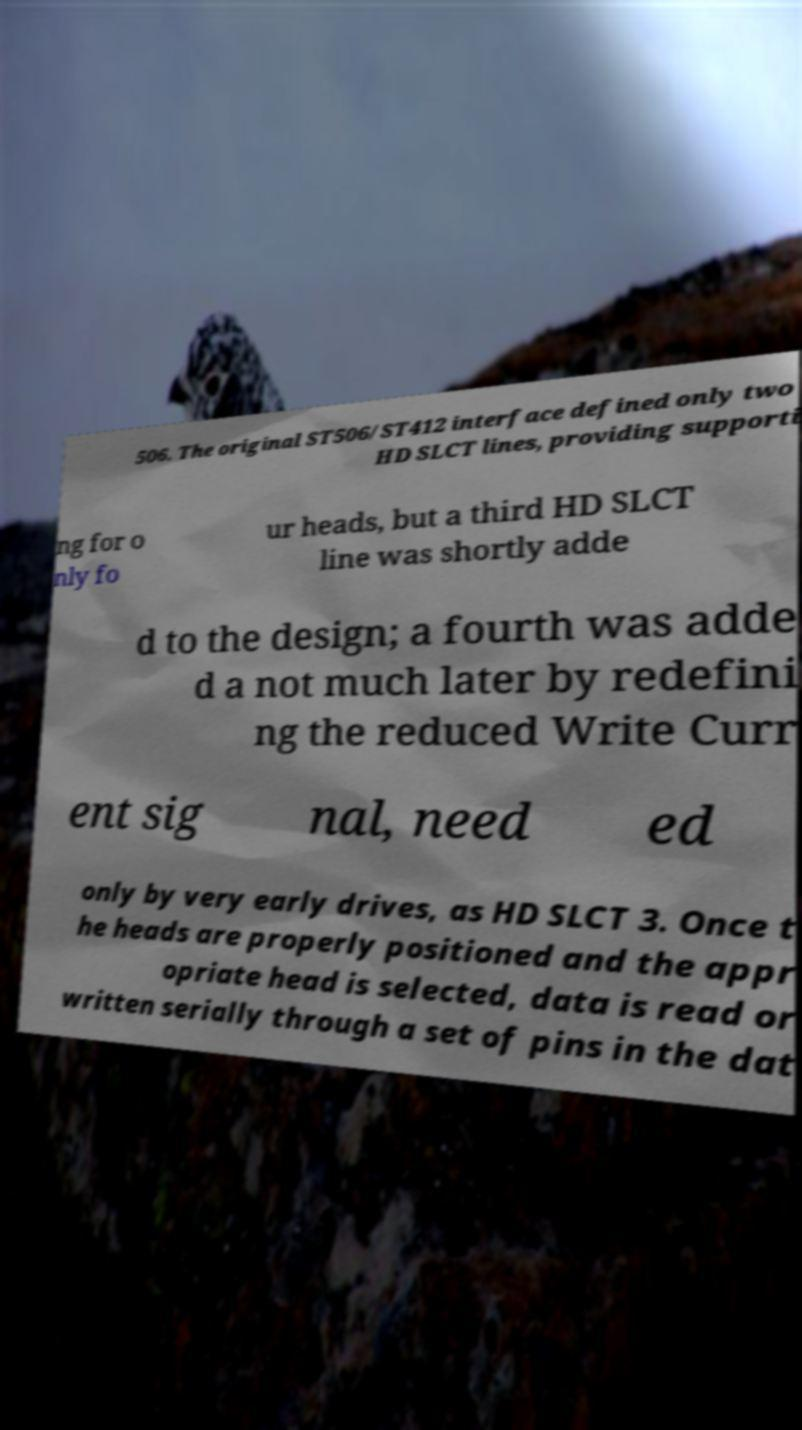What messages or text are displayed in this image? I need them in a readable, typed format. 506. The original ST506/ST412 interface defined only two HD SLCT lines, providing supporti ng for o nly fo ur heads, but a third HD SLCT line was shortly adde d to the design; a fourth was adde d a not much later by redefini ng the reduced Write Curr ent sig nal, need ed only by very early drives, as HD SLCT 3. Once t he heads are properly positioned and the appr opriate head is selected, data is read or written serially through a set of pins in the dat 